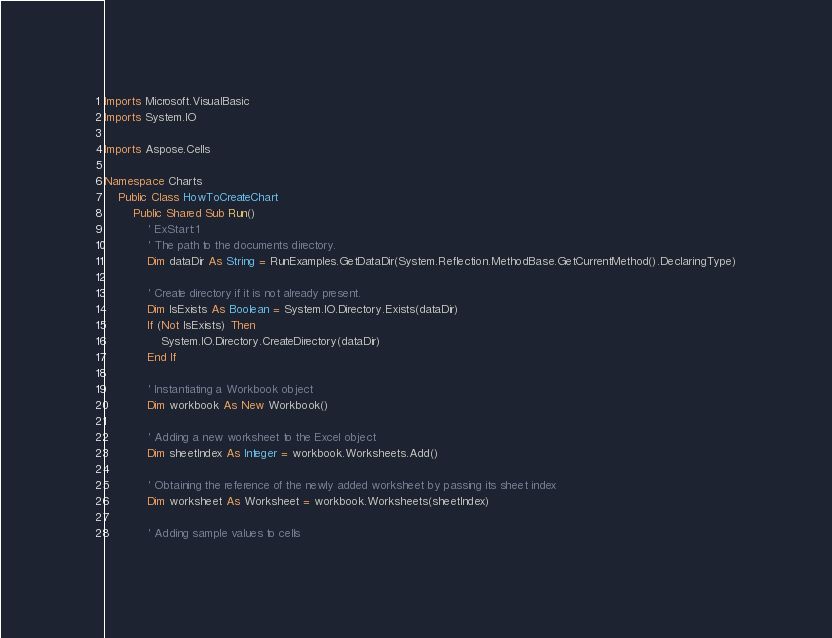Convert code to text. <code><loc_0><loc_0><loc_500><loc_500><_VisualBasic_>Imports Microsoft.VisualBasic
Imports System.IO

Imports Aspose.Cells

Namespace Charts
    Public Class HowToCreateChart
        Public Shared Sub Run()
            ' ExStart:1
            ' The path to the documents directory.
            Dim dataDir As String = RunExamples.GetDataDir(System.Reflection.MethodBase.GetCurrentMethod().DeclaringType)

            ' Create directory if it is not already present.
            Dim IsExists As Boolean = System.IO.Directory.Exists(dataDir)
            If (Not IsExists) Then
                System.IO.Directory.CreateDirectory(dataDir)
            End If

            ' Instantiating a Workbook object
            Dim workbook As New Workbook()

            ' Adding a new worksheet to the Excel object
            Dim sheetIndex As Integer = workbook.Worksheets.Add()

            ' Obtaining the reference of the newly added worksheet by passing its sheet index
            Dim worksheet As Worksheet = workbook.Worksheets(sheetIndex)

            ' Adding sample values to cells</code> 